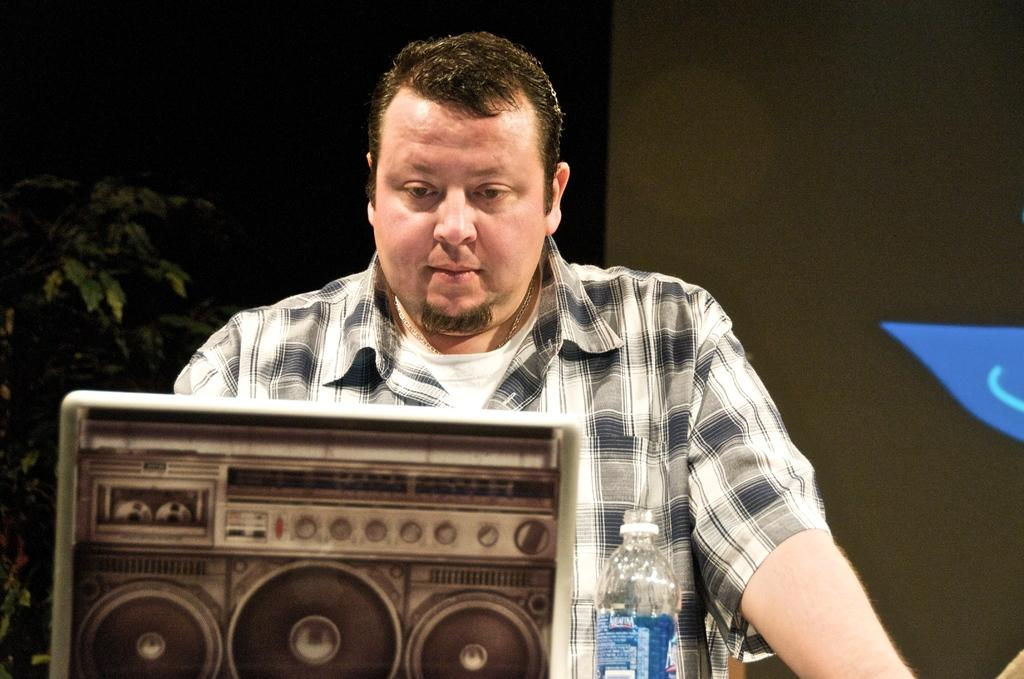What is the main subject of the image? There is a man in the image. What object can be seen with the man? There is an electronic device in the image. What other items are present in the image? There is a bottle and a plant in the image. What type of metal can be seen in the man's mouth in the image? There is no metal visible in the man's mouth in the image. What type of exchange is taking place between the man and the electronic device in the image? There is no exchange taking place between the man and the electronic device in the image. 